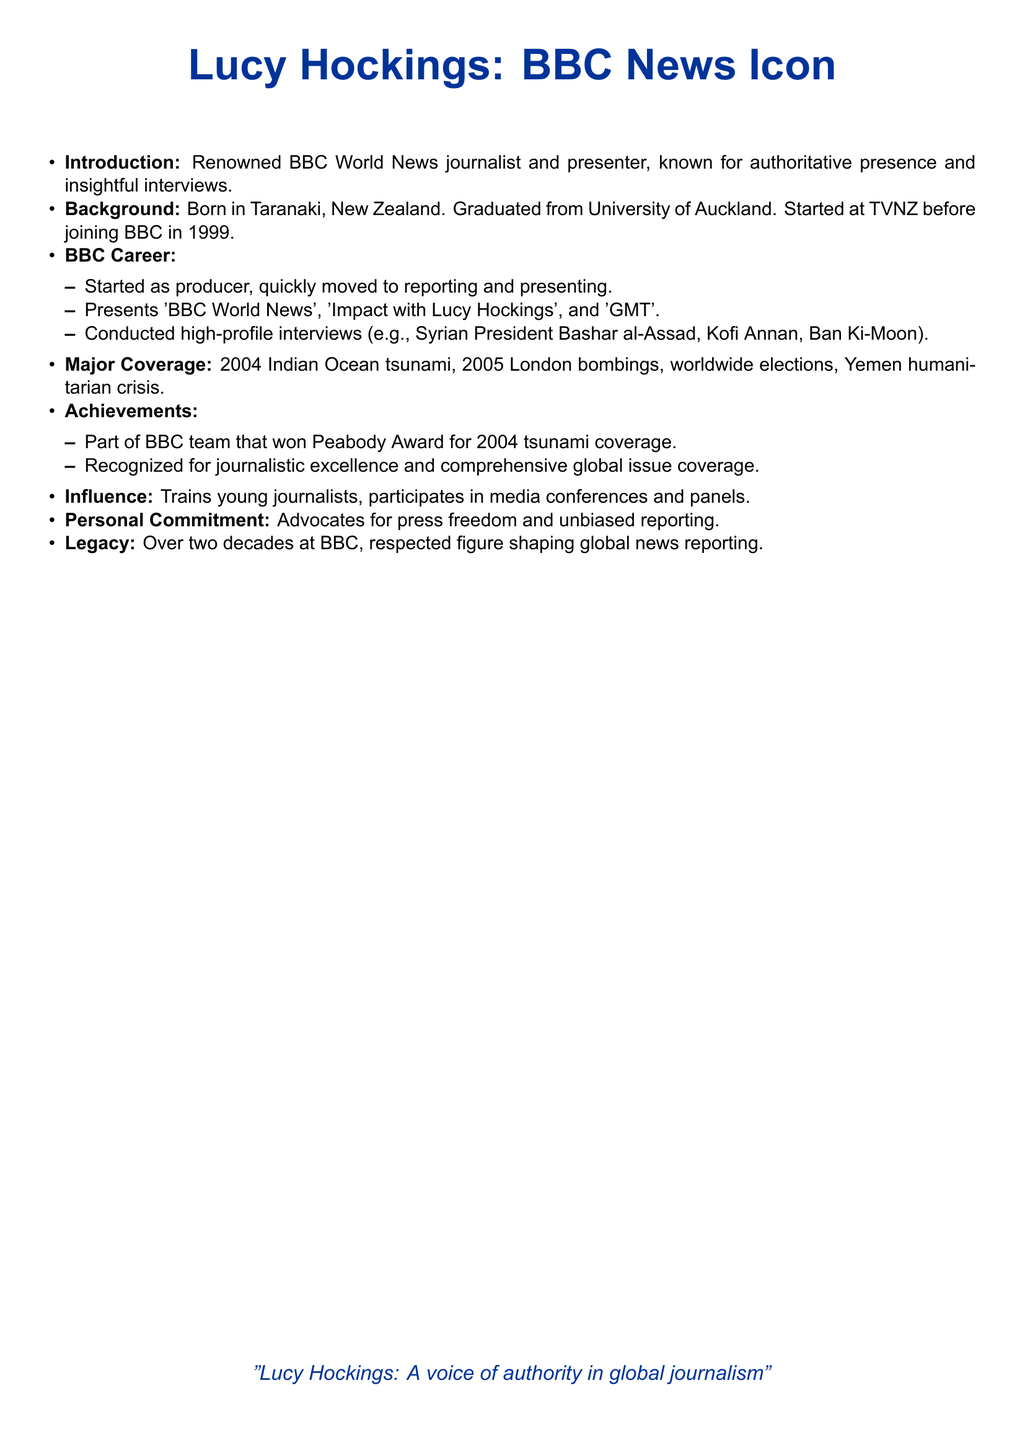What is Lucy Hockings' profession? Lucy Hockings is a renowned journalist and presenter at BBC World News.
Answer: journalist Where was Lucy Hockings born? The document states that Lucy Hockings was born in Taranaki, New Zealand.
Answer: Taranaki Which university did Lucy Hockings graduate from? Lucy Hockings graduated from the University of Auckland.
Answer: University of Auckland In what year did Lucy Hockings join the BBC? The document mentions that Lucy Hockings joined the BBC in 1999.
Answer: 1999 What award did Lucy Hockings' team win for their coverage of the tsunami? The document states that Lucy Hockings' team won a Peabody Award for coverage of the 2004 tsunami.
Answer: Peabody Award Who was one of the high-profile individuals interviewed by Lucy Hockings? The document lists several individuals, including Syrian President Bashar al-Assad, who was interviewed by Lucy Hockings.
Answer: Bashar al-Assad What major global event did Lucy Hockings cover in 2005? Lucy Hockings covered the London bombings in 2005.
Answer: London bombings What is Lucy Hockings' personal commitment mentioned in the document? The document states that Lucy Hockings advocates for press freedom and unbiased reporting.
Answer: press freedom Which program does Lucy Hockings present? The document lists 'Impact with Lucy Hockings' among the programs she presents.
Answer: Impact with Lucy Hockings 